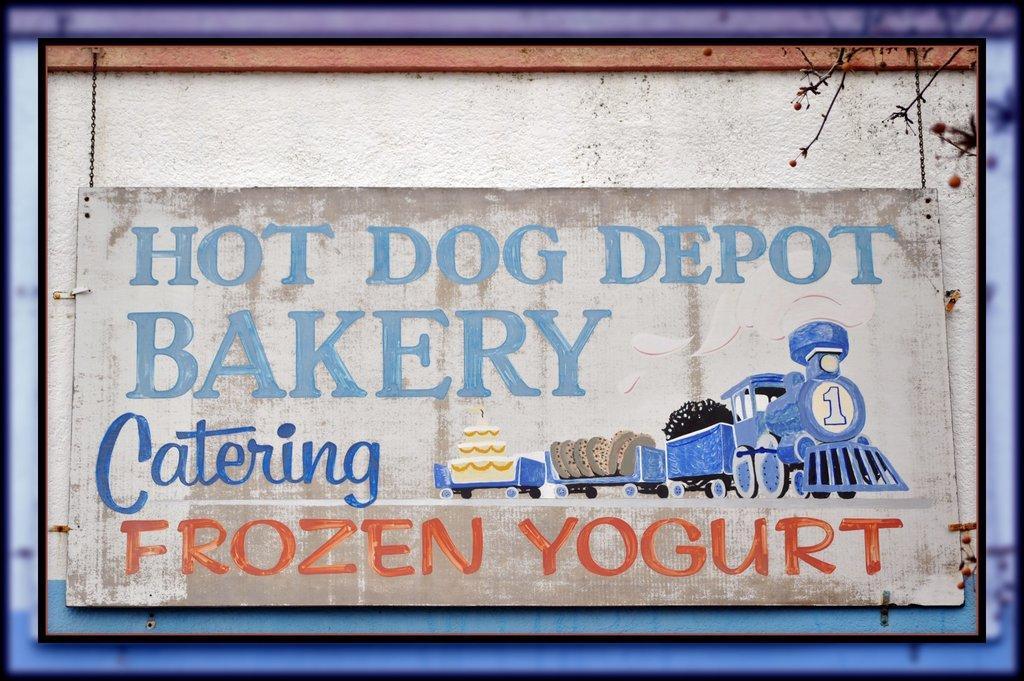Could you give a brief overview of what you see in this image? In this image I can see the board. On the board I can see the painting of the train and something is written on it. To the right I can see the tree. 